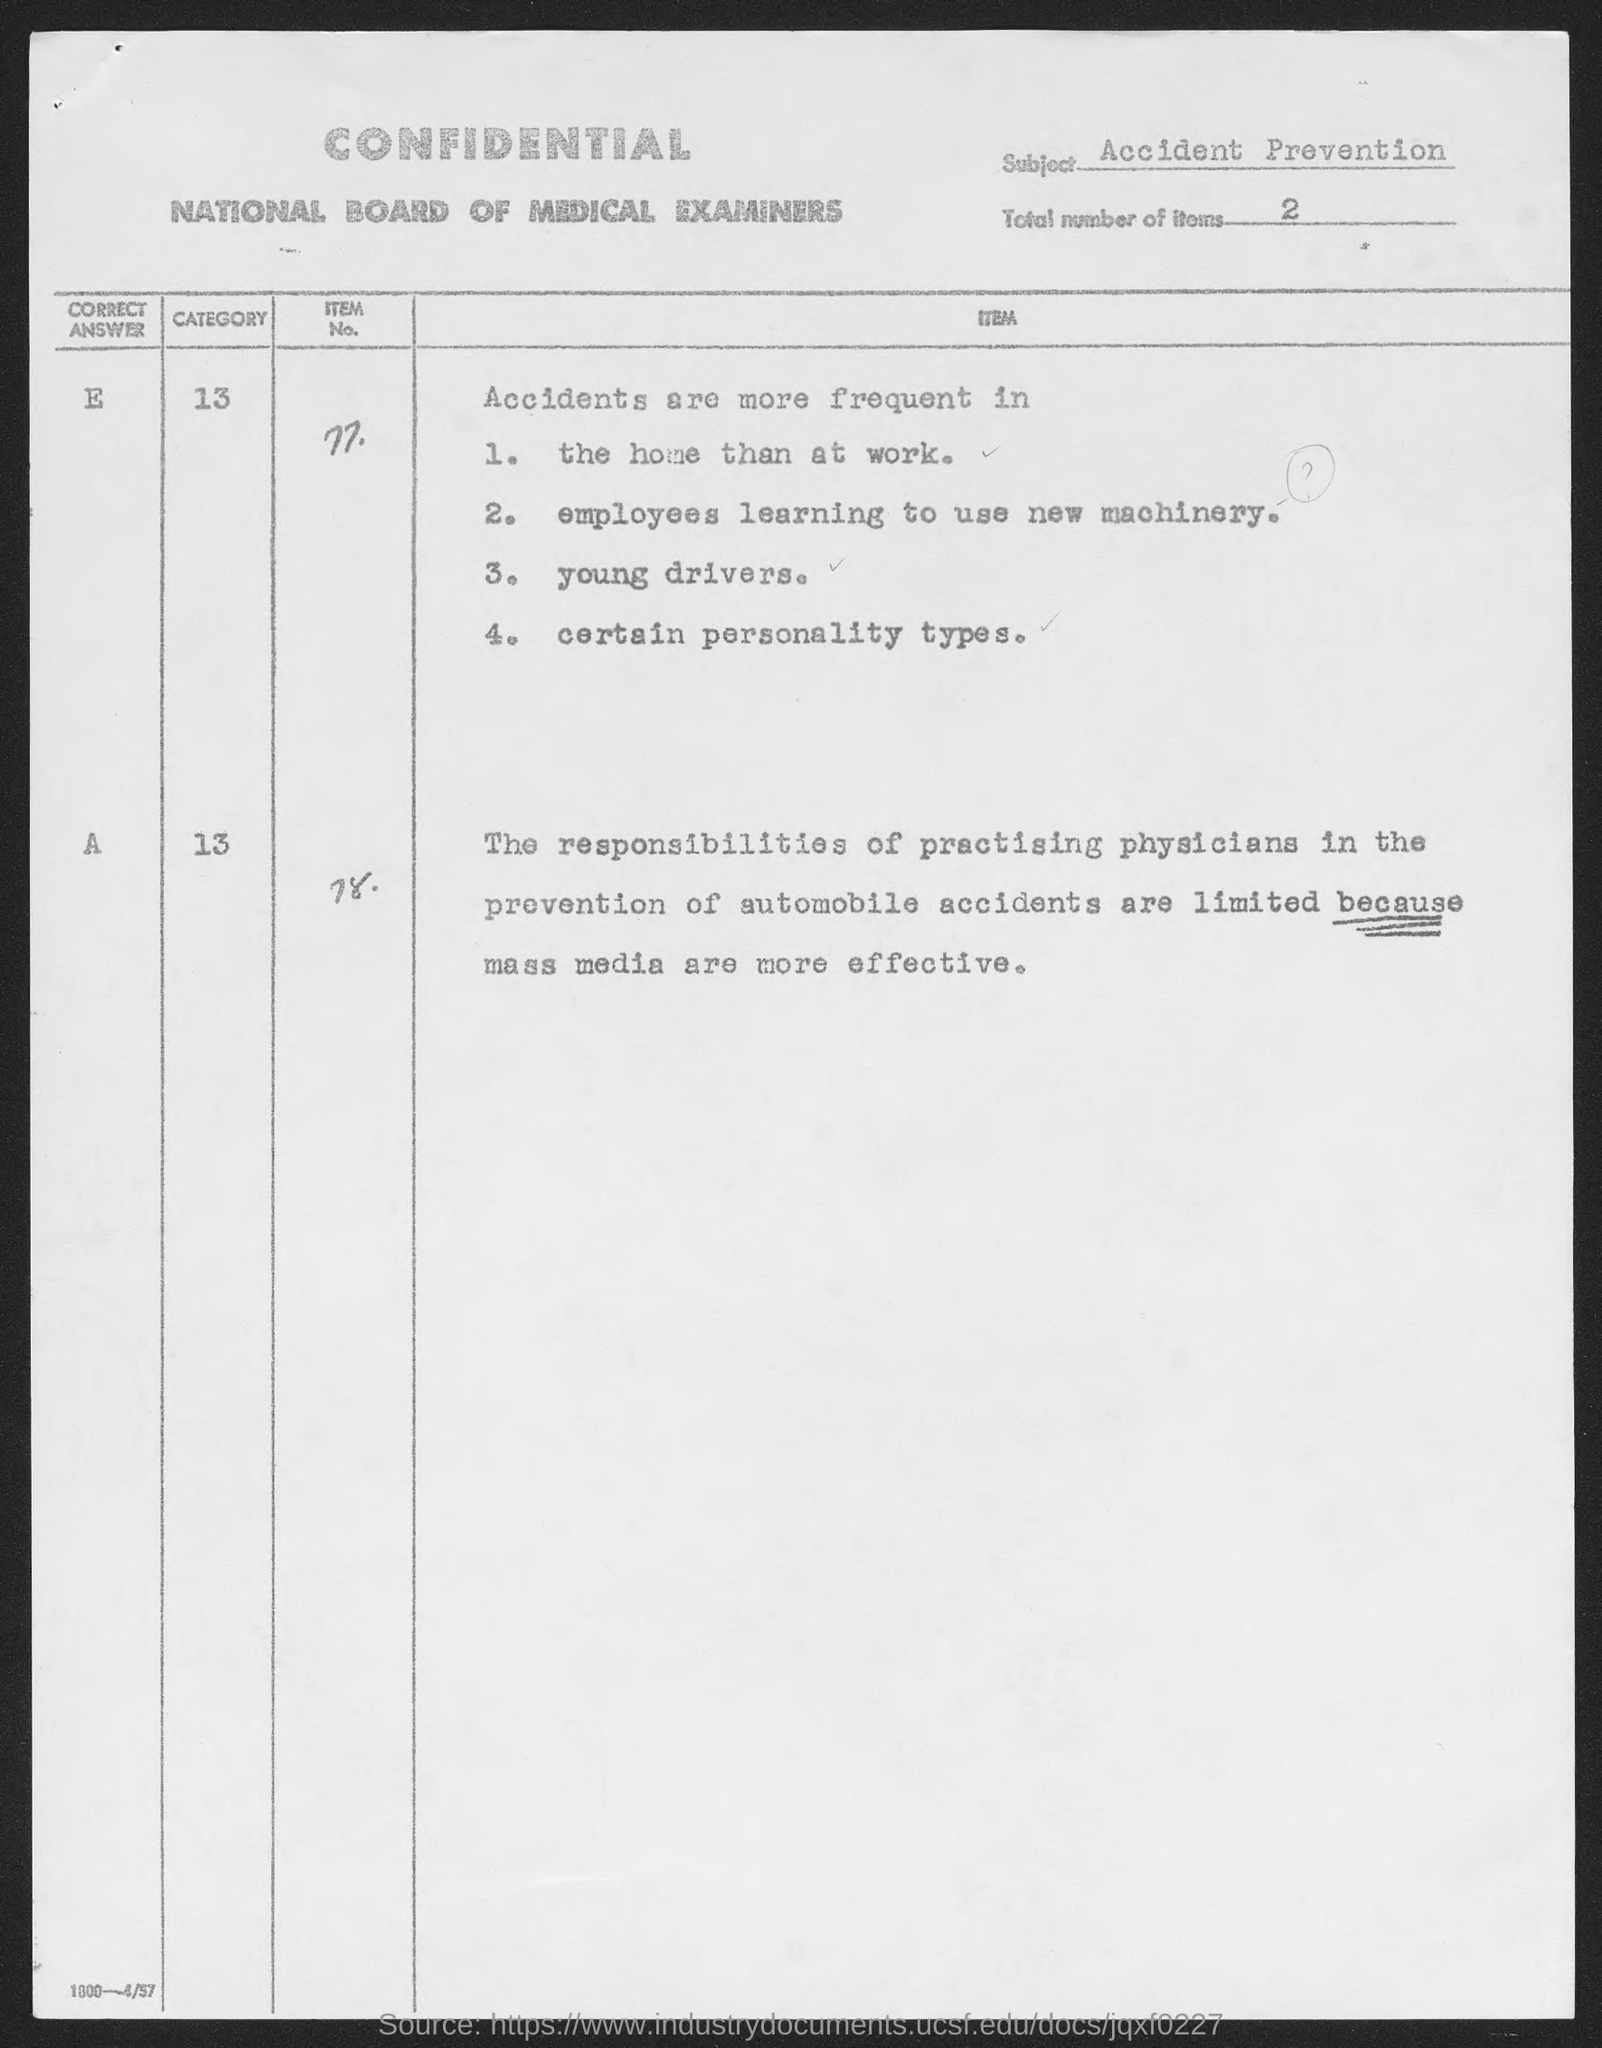What is the subject name?
Your answer should be very brief. Accident Prevention. What is the total number of items?
Provide a succinct answer. 2. What is the first item no?
Your answer should be compact. 77. What is the scond item no?
Keep it short and to the point. 78. What is the first point in for item no 77?
Keep it short and to the point. 1. the home than at work. What is the second point in item no 77?
Make the answer very short. Employees learning to use new machinery. What is the third point in item no 77?
Give a very brief answer. Young drivers. What is the fourth point in item no 77?
Ensure brevity in your answer.  Certain personality types. What is the heading of first column?
Provide a succinct answer. Correct Answer. 